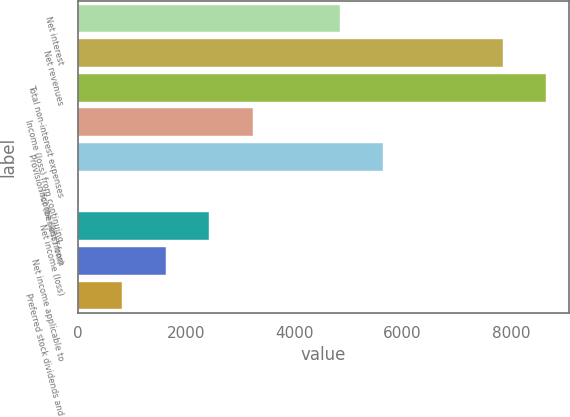<chart> <loc_0><loc_0><loc_500><loc_500><bar_chart><fcel>Net interest<fcel>Net revenues<fcel>Total non-interest expenses<fcel>Income (loss) from continuing<fcel>Provision for (benefit from)<fcel>Income (loss) from<fcel>Net income (loss)<fcel>Net income applicable to<fcel>Preferred stock dividends and<nl><fcel>4833.8<fcel>7845<fcel>8648.3<fcel>3227.2<fcel>5637.1<fcel>14<fcel>2423.9<fcel>1620.6<fcel>817.3<nl></chart> 